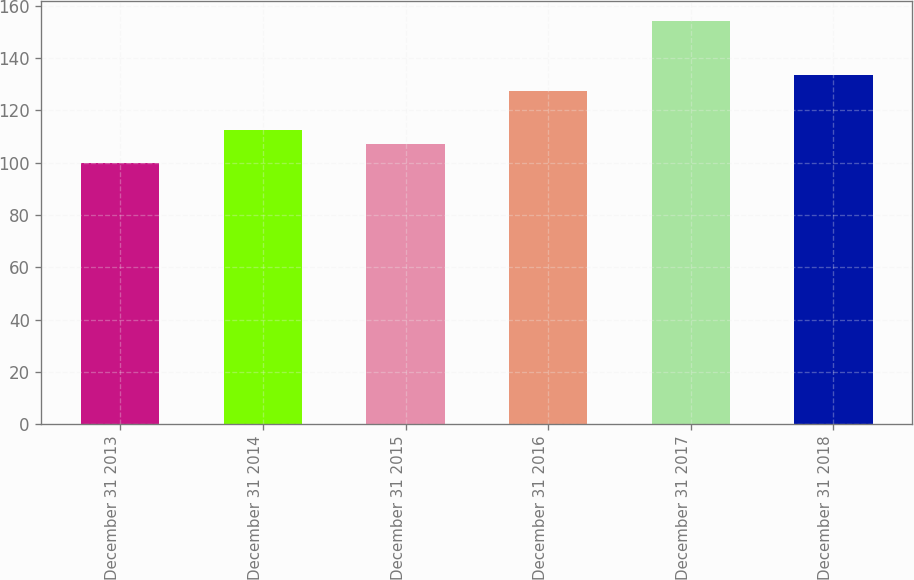Convert chart. <chart><loc_0><loc_0><loc_500><loc_500><bar_chart><fcel>December 31 2013<fcel>December 31 2014<fcel>December 31 2015<fcel>December 31 2016<fcel>December 31 2017<fcel>December 31 2018<nl><fcel>100<fcel>112.44<fcel>107.04<fcel>127.23<fcel>153.99<fcel>133.53<nl></chart> 